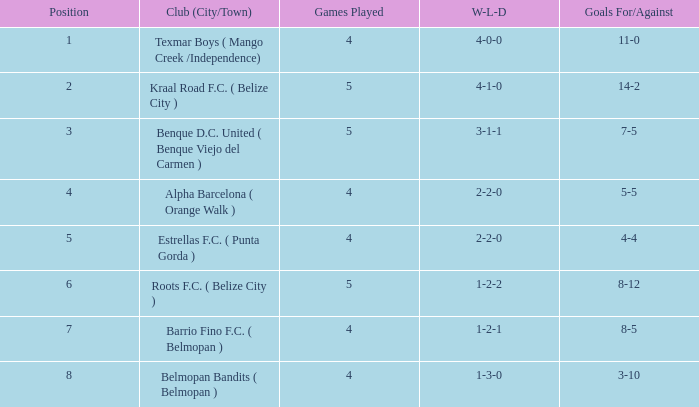Who is the the club (city/town) with goals for/against being 14-2 Kraal Road F.C. ( Belize City ). 